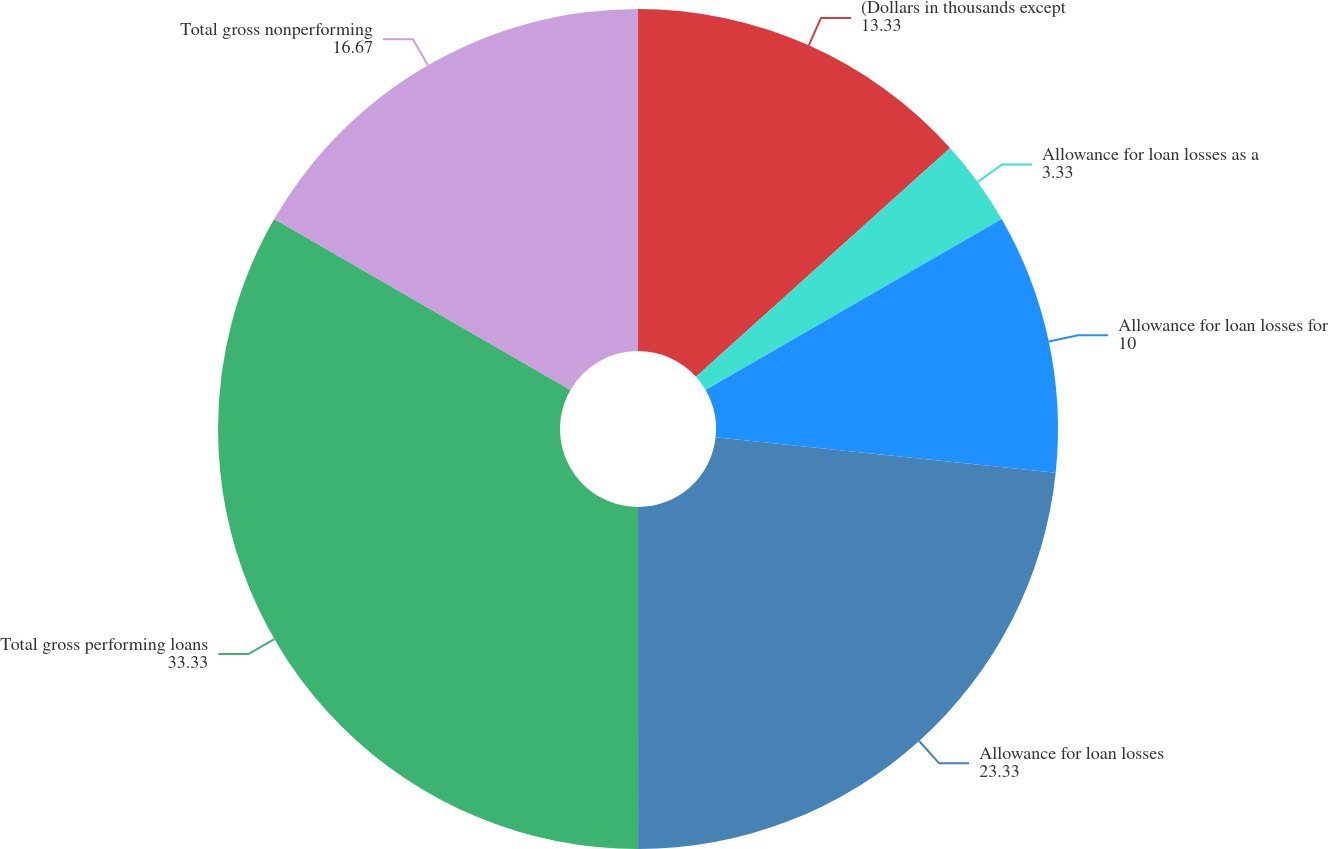Convert chart. <chart><loc_0><loc_0><loc_500><loc_500><pie_chart><fcel>(Dollars in thousands except<fcel>Allowance for loan losses as a<fcel>Allowance for loan losses for<fcel>Allowance for loan losses<fcel>Total gross performing loans<fcel>Total gross nonperforming<nl><fcel>13.33%<fcel>3.33%<fcel>10.0%<fcel>23.33%<fcel>33.33%<fcel>16.67%<nl></chart> 